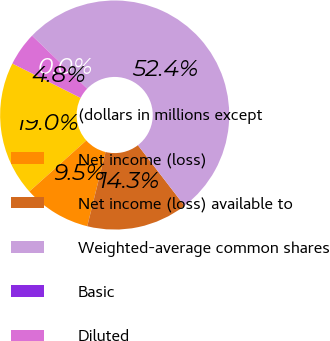<chart> <loc_0><loc_0><loc_500><loc_500><pie_chart><fcel>(dollars in millions except<fcel>Net income (loss)<fcel>Net income (loss) available to<fcel>Weighted-average common shares<fcel>Basic<fcel>Diluted<nl><fcel>19.05%<fcel>9.52%<fcel>14.29%<fcel>52.38%<fcel>0.0%<fcel>4.76%<nl></chart> 